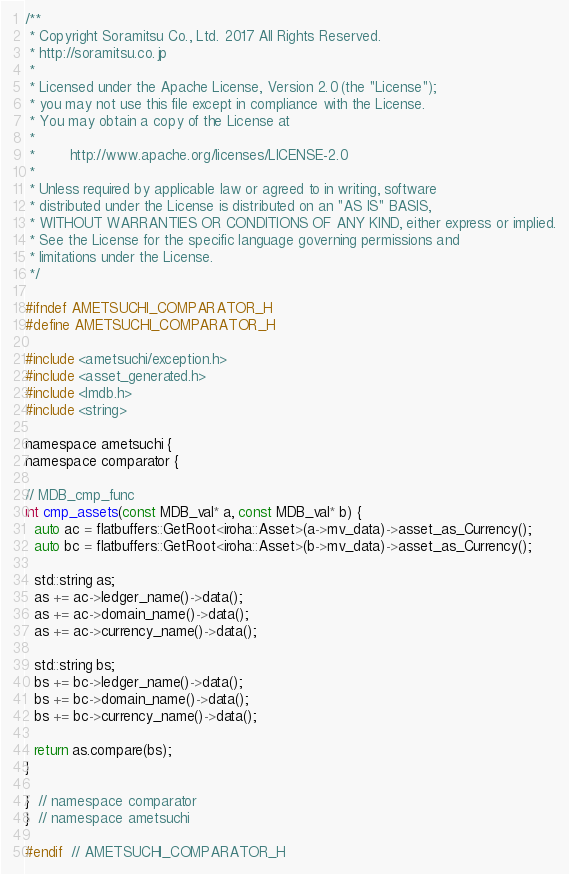<code> <loc_0><loc_0><loc_500><loc_500><_C_>/**
 * Copyright Soramitsu Co., Ltd. 2017 All Rights Reserved.
 * http://soramitsu.co.jp
 *
 * Licensed under the Apache License, Version 2.0 (the "License");
 * you may not use this file except in compliance with the License.
 * You may obtain a copy of the License at
 *
 *        http://www.apache.org/licenses/LICENSE-2.0
 *
 * Unless required by applicable law or agreed to in writing, software
 * distributed under the License is distributed on an "AS IS" BASIS,
 * WITHOUT WARRANTIES OR CONDITIONS OF ANY KIND, either express or implied.
 * See the License for the specific language governing permissions and
 * limitations under the License.
 */

#ifndef AMETSUCHI_COMPARATOR_H
#define AMETSUCHI_COMPARATOR_H

#include <ametsuchi/exception.h>
#include <asset_generated.h>
#include <lmdb.h>
#include <string>

namespace ametsuchi {
namespace comparator {

// MDB_cmp_func
int cmp_assets(const MDB_val* a, const MDB_val* b) {
  auto ac = flatbuffers::GetRoot<iroha::Asset>(a->mv_data)->asset_as_Currency();
  auto bc = flatbuffers::GetRoot<iroha::Asset>(b->mv_data)->asset_as_Currency();

  std::string as;
  as += ac->ledger_name()->data();
  as += ac->domain_name()->data();
  as += ac->currency_name()->data();

  std::string bs;
  bs += bc->ledger_name()->data();
  bs += bc->domain_name()->data();
  bs += bc->currency_name()->data();

  return as.compare(bs);
}

}  // namespace comparator
}  // namespace ametsuchi

#endif  // AMETSUCHI_COMPARATOR_H
</code> 